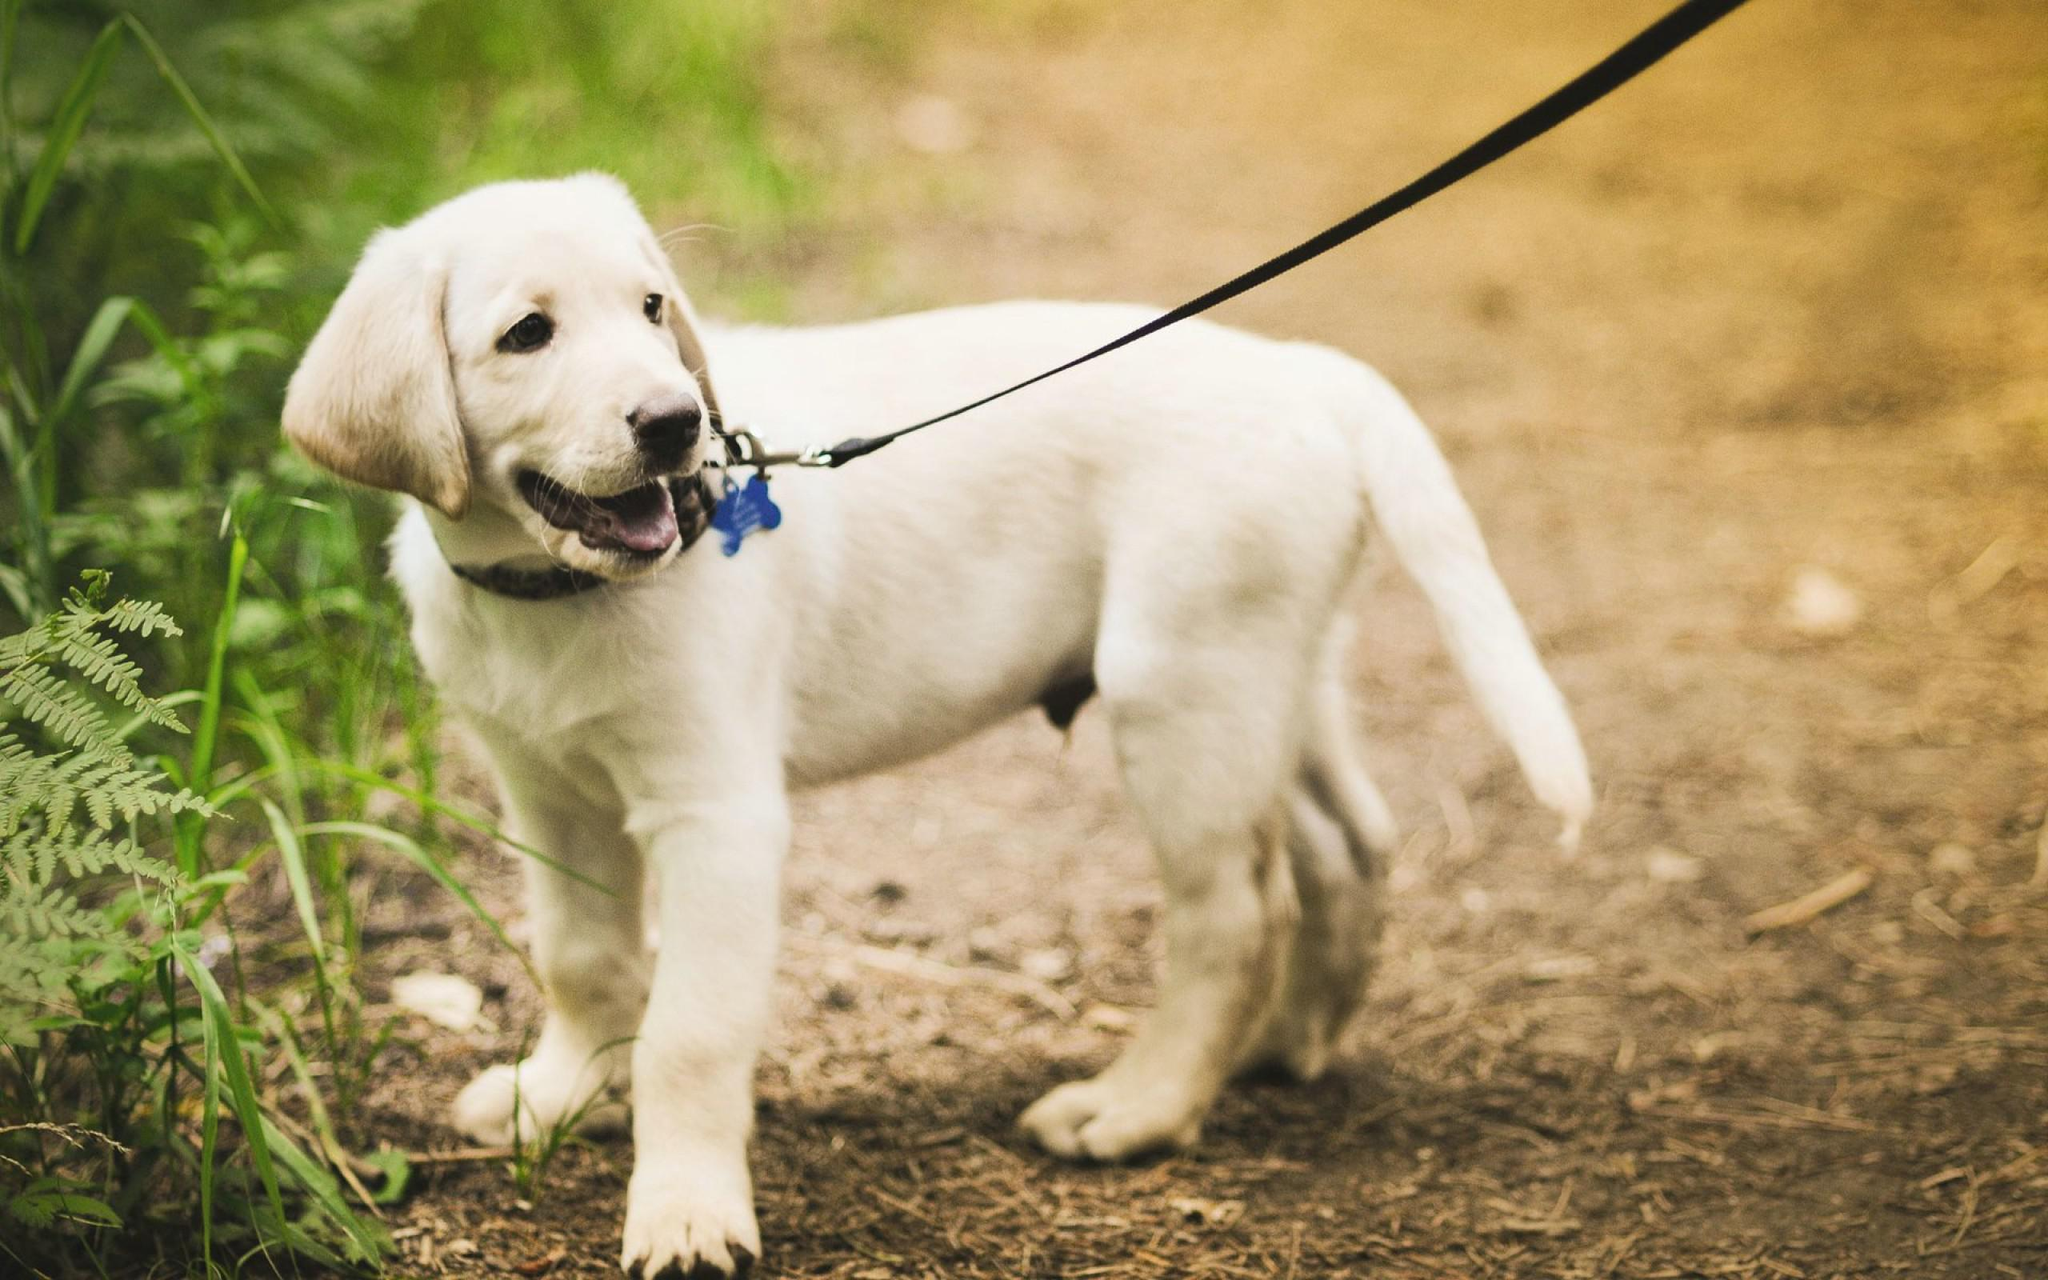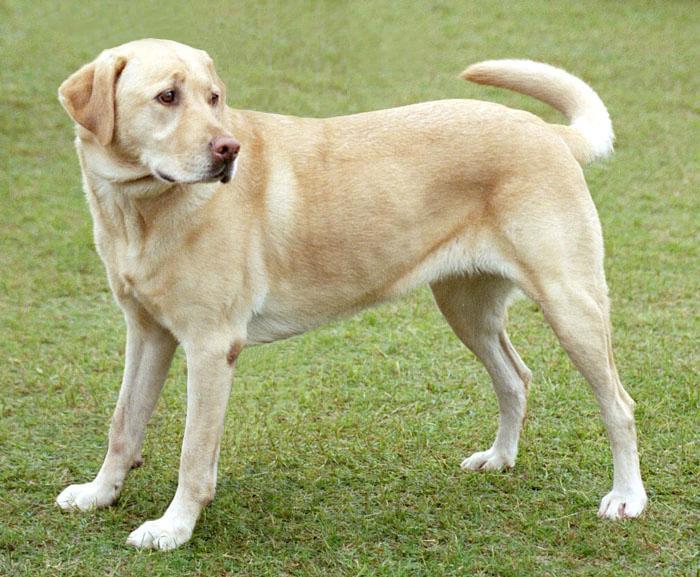The first image is the image on the left, the second image is the image on the right. Considering the images on both sides, is "One of the animals is not on the grass." valid? Answer yes or no. No. 